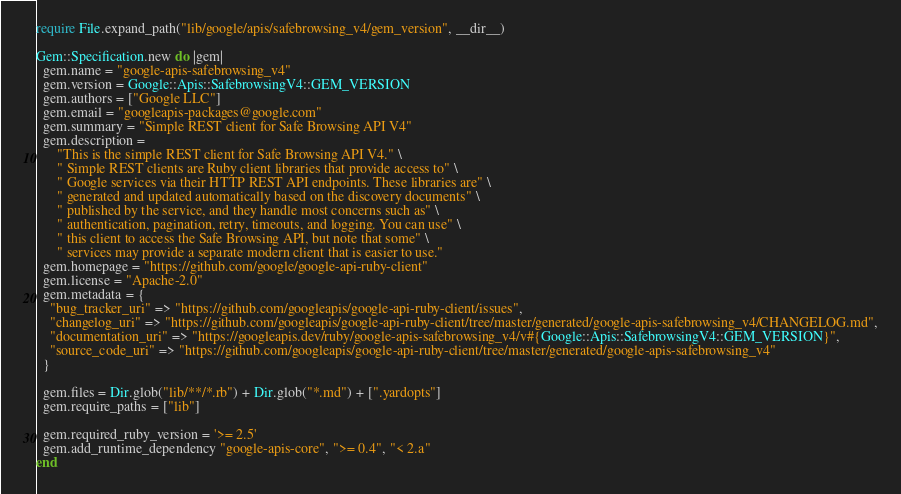<code> <loc_0><loc_0><loc_500><loc_500><_Ruby_>require File.expand_path("lib/google/apis/safebrowsing_v4/gem_version", __dir__)

Gem::Specification.new do |gem|
  gem.name = "google-apis-safebrowsing_v4"
  gem.version = Google::Apis::SafebrowsingV4::GEM_VERSION
  gem.authors = ["Google LLC"]
  gem.email = "googleapis-packages@google.com"
  gem.summary = "Simple REST client for Safe Browsing API V4"
  gem.description =
      "This is the simple REST client for Safe Browsing API V4." \
      " Simple REST clients are Ruby client libraries that provide access to" \
      " Google services via their HTTP REST API endpoints. These libraries are" \
      " generated and updated automatically based on the discovery documents" \
      " published by the service, and they handle most concerns such as" \
      " authentication, pagination, retry, timeouts, and logging. You can use" \
      " this client to access the Safe Browsing API, but note that some" \
      " services may provide a separate modern client that is easier to use."
  gem.homepage = "https://github.com/google/google-api-ruby-client"
  gem.license = "Apache-2.0"
  gem.metadata = {
    "bug_tracker_uri" => "https://github.com/googleapis/google-api-ruby-client/issues",
    "changelog_uri" => "https://github.com/googleapis/google-api-ruby-client/tree/master/generated/google-apis-safebrowsing_v4/CHANGELOG.md",
    "documentation_uri" => "https://googleapis.dev/ruby/google-apis-safebrowsing_v4/v#{Google::Apis::SafebrowsingV4::GEM_VERSION}",
    "source_code_uri" => "https://github.com/googleapis/google-api-ruby-client/tree/master/generated/google-apis-safebrowsing_v4"
  }

  gem.files = Dir.glob("lib/**/*.rb") + Dir.glob("*.md") + [".yardopts"]
  gem.require_paths = ["lib"]

  gem.required_ruby_version = '>= 2.5'
  gem.add_runtime_dependency "google-apis-core", ">= 0.4", "< 2.a"
end
</code> 